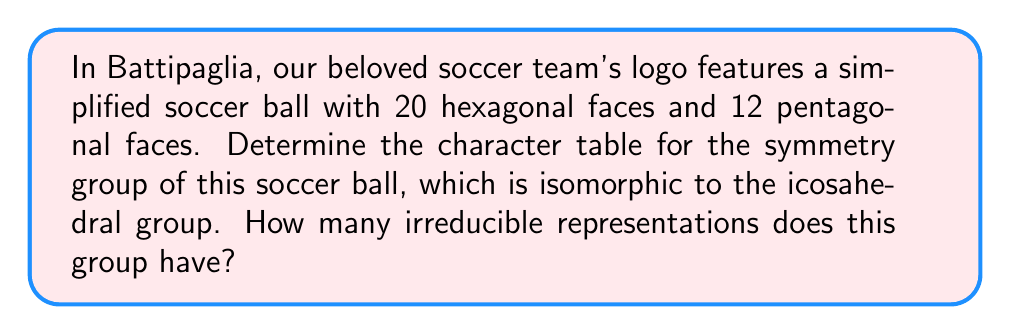Help me with this question. Let's approach this step-by-step:

1) The symmetry group of a soccer ball is isomorphic to the icosahedral group, which is also known as $A_5$, the alternating group on 5 elements.

2) To determine the character table, we need to find the conjugacy classes and irreducible representations:

   a) Conjugacy classes of $A_5$:
      - $e$: identity (1 element)
      - $(123)$: 3-cycles (20 elements)
      - $(12)(34)$: product of two 2-cycles (15 elements)
      - $(12345)$: 5-cycles (12 elements)
      - $(13524)$: 5-cycles (12 elements)

3) The number of irreducible representations is equal to the number of conjugacy classes, which is 5.

4) The character table will be a 5x5 matrix. We can determine it as follows:

   $$\begin{array}{c|ccccc}
      & e & (123) & (12)(34) & (12345) & (13524) \\
   \hline
   \chi_1 & 1 & 1 & 1 & 1 & 1 \\
   \chi_2 & 3 & 0 & -1 & \frac{1+\sqrt{5}}{2} & \frac{1-\sqrt{5}}{2} \\
   \chi_3 & 3 & 0 & -1 & \frac{1-\sqrt{5}}{2} & \frac{1+\sqrt{5}}{2} \\
   \chi_4 & 4 & 1 & 0 & -1 & -1 \\
   \chi_5 & 5 & -1 & 1 & 0 & 0
   \end{array}$$

5) Each row in this table represents an irreducible representation, and each column represents a conjugacy class.
Answer: 5 irreducible representations 